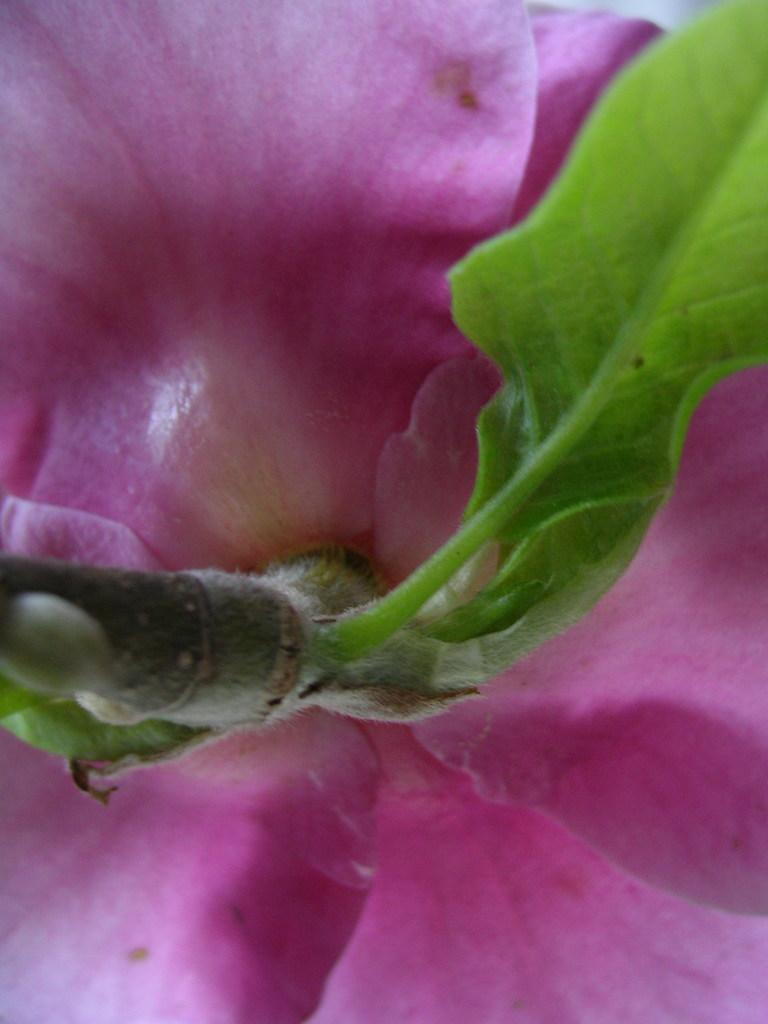What is the main subject of the image? The main subject of the image is a flower. What are the main parts of the flower visible in the image? The flower has petals and a leaf. What type of wheel can be seen attached to the flower in the image? There is no wheel present in the image; it is a closeup view of a flower with petals and a leaf. 